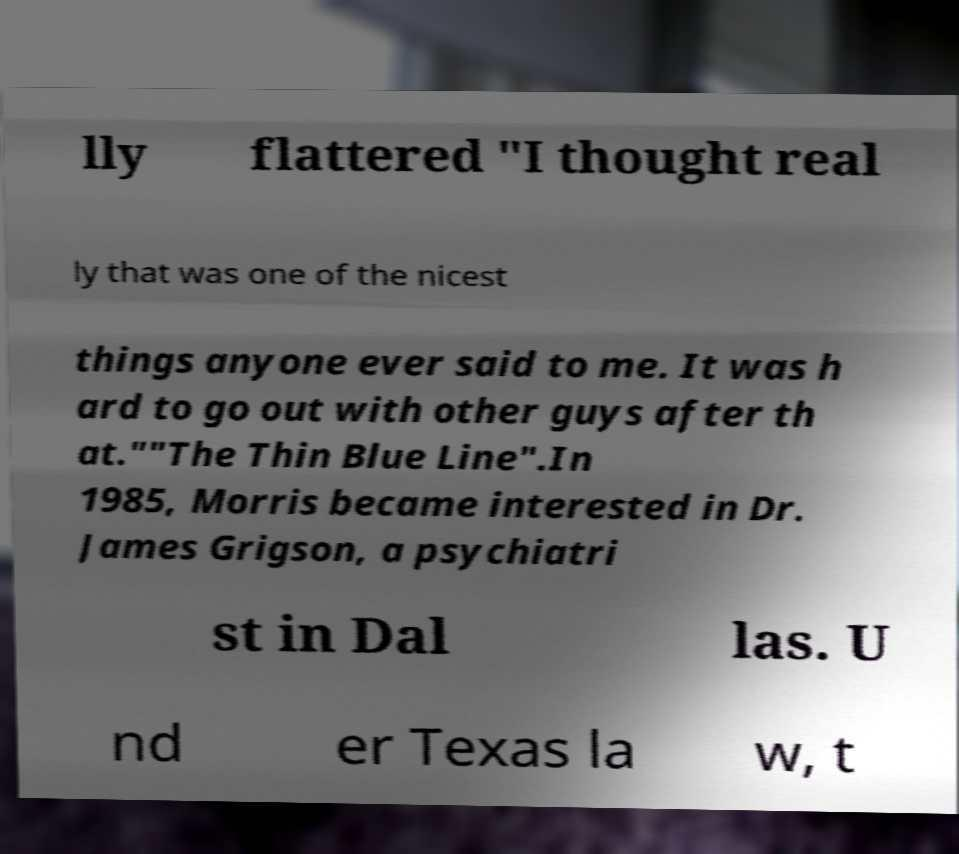Can you accurately transcribe the text from the provided image for me? lly flattered "I thought real ly that was one of the nicest things anyone ever said to me. It was h ard to go out with other guys after th at.""The Thin Blue Line".In 1985, Morris became interested in Dr. James Grigson, a psychiatri st in Dal las. U nd er Texas la w, t 